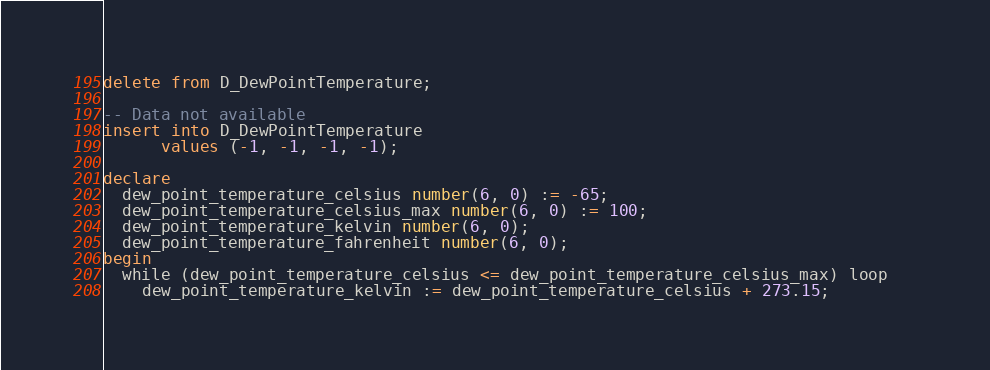<code> <loc_0><loc_0><loc_500><loc_500><_SQL_>delete from D_DewPointTemperature;

-- Data not available
insert into D_DewPointTemperature
      values (-1, -1, -1, -1);

declare
  dew_point_temperature_celsius number(6, 0) := -65;
  dew_point_temperature_celsius_max number(6, 0) := 100;
  dew_point_temperature_kelvin number(6, 0);
  dew_point_temperature_fahrenheit number(6, 0);
begin
  while (dew_point_temperature_celsius <= dew_point_temperature_celsius_max) loop   
    dew_point_temperature_kelvin := dew_point_temperature_celsius + 273.15;</code> 